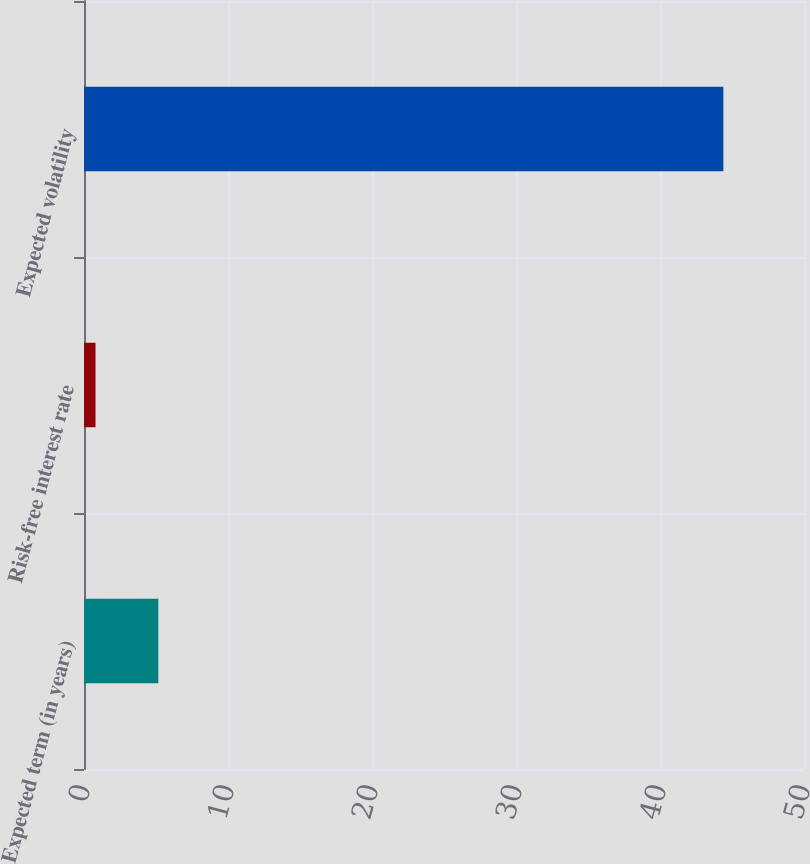Convert chart to OTSL. <chart><loc_0><loc_0><loc_500><loc_500><bar_chart><fcel>Expected term (in years)<fcel>Risk-free interest rate<fcel>Expected volatility<nl><fcel>5.16<fcel>0.8<fcel>44.4<nl></chart> 